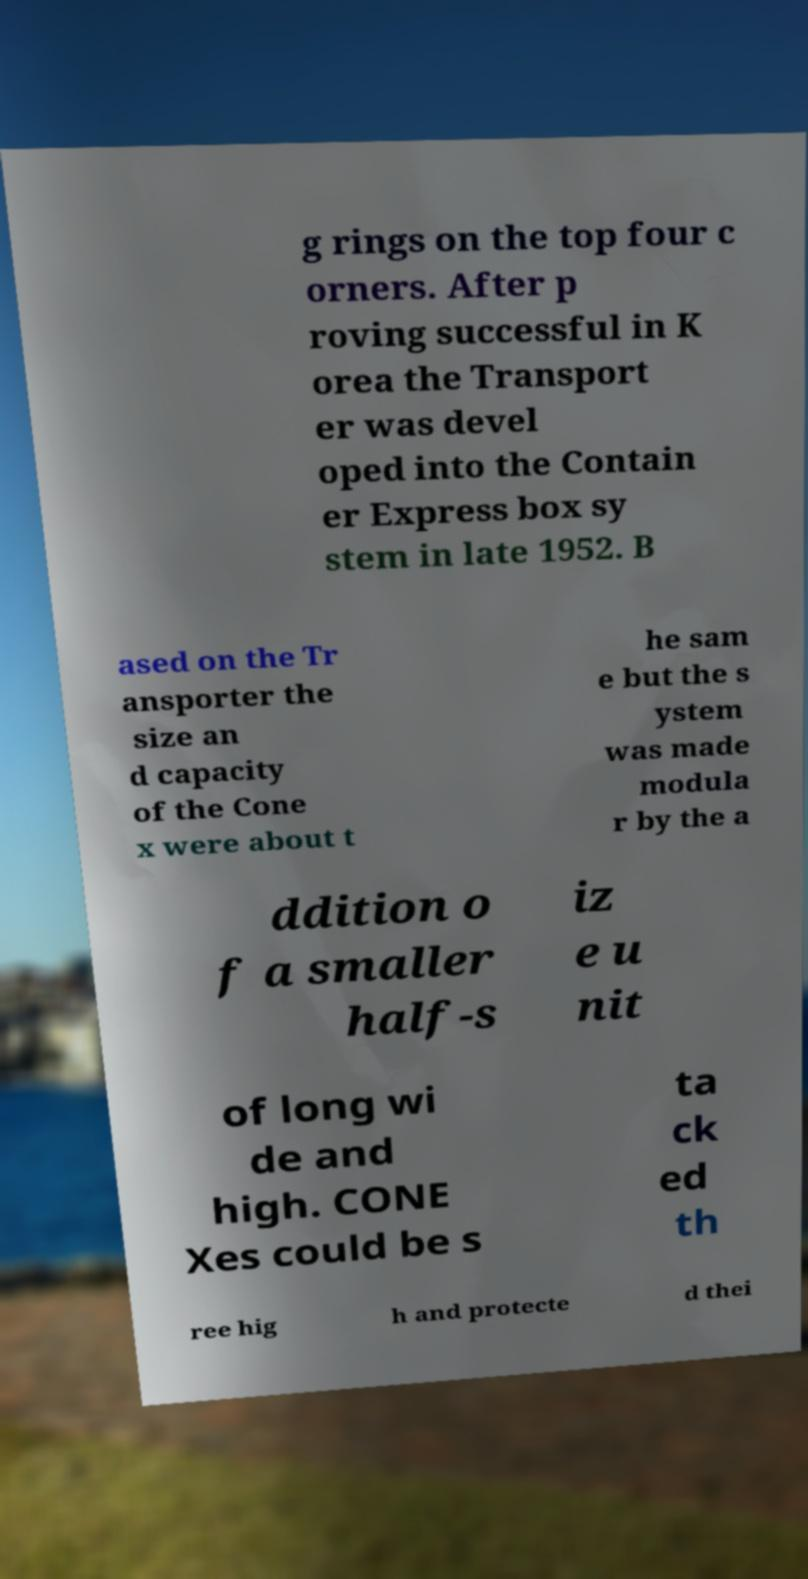For documentation purposes, I need the text within this image transcribed. Could you provide that? g rings on the top four c orners. After p roving successful in K orea the Transport er was devel oped into the Contain er Express box sy stem in late 1952. B ased on the Tr ansporter the size an d capacity of the Cone x were about t he sam e but the s ystem was made modula r by the a ddition o f a smaller half-s iz e u nit of long wi de and high. CONE Xes could be s ta ck ed th ree hig h and protecte d thei 